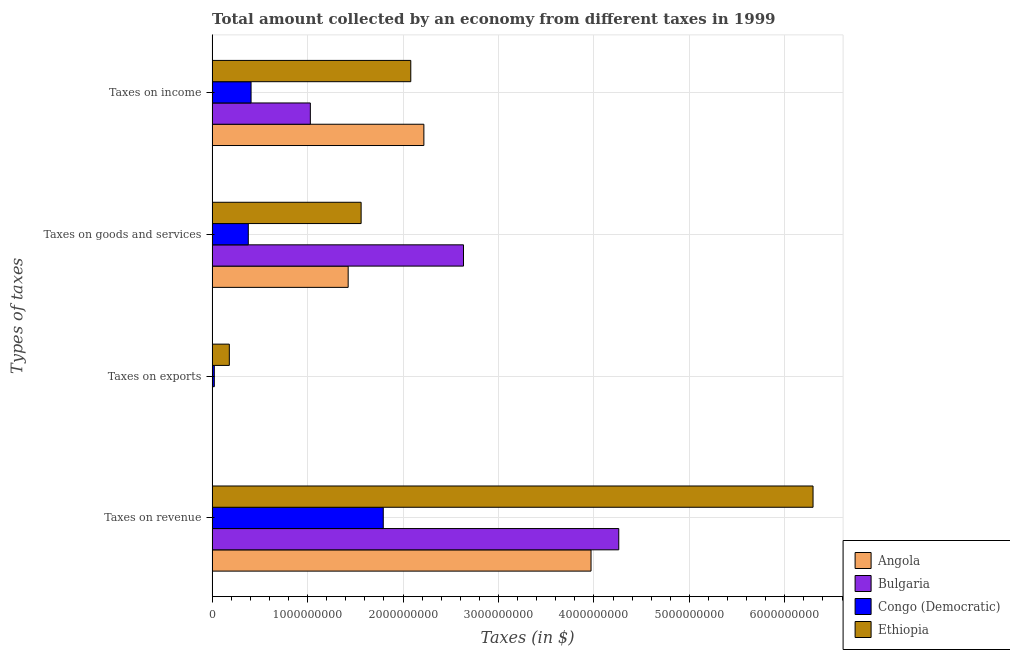How many different coloured bars are there?
Offer a very short reply. 4. Are the number of bars on each tick of the Y-axis equal?
Keep it short and to the point. Yes. How many bars are there on the 3rd tick from the bottom?
Make the answer very short. 4. What is the label of the 1st group of bars from the top?
Make the answer very short. Taxes on income. What is the amount collected as tax on goods in Congo (Democratic)?
Ensure brevity in your answer.  3.79e+08. Across all countries, what is the maximum amount collected as tax on income?
Offer a terse response. 2.22e+09. Across all countries, what is the minimum amount collected as tax on income?
Make the answer very short. 4.08e+08. In which country was the amount collected as tax on revenue maximum?
Provide a succinct answer. Ethiopia. In which country was the amount collected as tax on revenue minimum?
Offer a terse response. Congo (Democratic). What is the total amount collected as tax on goods in the graph?
Provide a short and direct response. 6.00e+09. What is the difference between the amount collected as tax on goods in Angola and that in Ethiopia?
Keep it short and to the point. -1.36e+08. What is the difference between the amount collected as tax on income in Ethiopia and the amount collected as tax on goods in Angola?
Offer a terse response. 6.56e+08. What is the average amount collected as tax on exports per country?
Provide a succinct answer. 5.16e+07. What is the difference between the amount collected as tax on revenue and amount collected as tax on income in Bulgaria?
Keep it short and to the point. 3.23e+09. What is the ratio of the amount collected as tax on goods in Congo (Democratic) to that in Ethiopia?
Your response must be concise. 0.24. Is the difference between the amount collected as tax on goods in Angola and Ethiopia greater than the difference between the amount collected as tax on revenue in Angola and Ethiopia?
Your answer should be very brief. Yes. What is the difference between the highest and the second highest amount collected as tax on revenue?
Make the answer very short. 2.04e+09. What is the difference between the highest and the lowest amount collected as tax on income?
Your answer should be very brief. 1.81e+09. What does the 3rd bar from the top in Taxes on exports represents?
Ensure brevity in your answer.  Bulgaria. What does the 4th bar from the bottom in Taxes on revenue represents?
Offer a very short reply. Ethiopia. Is it the case that in every country, the sum of the amount collected as tax on revenue and amount collected as tax on exports is greater than the amount collected as tax on goods?
Your answer should be very brief. Yes. Are all the bars in the graph horizontal?
Keep it short and to the point. Yes. How many countries are there in the graph?
Provide a short and direct response. 4. What is the difference between two consecutive major ticks on the X-axis?
Your response must be concise. 1.00e+09. Are the values on the major ticks of X-axis written in scientific E-notation?
Offer a very short reply. No. Does the graph contain grids?
Your answer should be compact. Yes. Where does the legend appear in the graph?
Offer a very short reply. Bottom right. How many legend labels are there?
Your answer should be very brief. 4. What is the title of the graph?
Provide a succinct answer. Total amount collected by an economy from different taxes in 1999. What is the label or title of the X-axis?
Your answer should be compact. Taxes (in $). What is the label or title of the Y-axis?
Keep it short and to the point. Types of taxes. What is the Taxes (in $) of Angola in Taxes on revenue?
Give a very brief answer. 3.97e+09. What is the Taxes (in $) in Bulgaria in Taxes on revenue?
Offer a terse response. 4.26e+09. What is the Taxes (in $) of Congo (Democratic) in Taxes on revenue?
Your response must be concise. 1.79e+09. What is the Taxes (in $) in Ethiopia in Taxes on revenue?
Your response must be concise. 6.30e+09. What is the Taxes (in $) in Angola in Taxes on exports?
Give a very brief answer. 3.22e+06. What is the Taxes (in $) in Bulgaria in Taxes on exports?
Your response must be concise. 6.80e+04. What is the Taxes (in $) of Congo (Democratic) in Taxes on exports?
Ensure brevity in your answer.  2.30e+07. What is the Taxes (in $) in Ethiopia in Taxes on exports?
Your answer should be very brief. 1.80e+08. What is the Taxes (in $) of Angola in Taxes on goods and services?
Provide a short and direct response. 1.43e+09. What is the Taxes (in $) of Bulgaria in Taxes on goods and services?
Provide a succinct answer. 2.63e+09. What is the Taxes (in $) of Congo (Democratic) in Taxes on goods and services?
Offer a very short reply. 3.79e+08. What is the Taxes (in $) of Ethiopia in Taxes on goods and services?
Make the answer very short. 1.56e+09. What is the Taxes (in $) of Angola in Taxes on income?
Provide a short and direct response. 2.22e+09. What is the Taxes (in $) in Bulgaria in Taxes on income?
Offer a very short reply. 1.03e+09. What is the Taxes (in $) in Congo (Democratic) in Taxes on income?
Keep it short and to the point. 4.08e+08. What is the Taxes (in $) in Ethiopia in Taxes on income?
Offer a very short reply. 2.08e+09. Across all Types of taxes, what is the maximum Taxes (in $) in Angola?
Make the answer very short. 3.97e+09. Across all Types of taxes, what is the maximum Taxes (in $) of Bulgaria?
Your answer should be very brief. 4.26e+09. Across all Types of taxes, what is the maximum Taxes (in $) in Congo (Democratic)?
Ensure brevity in your answer.  1.79e+09. Across all Types of taxes, what is the maximum Taxes (in $) of Ethiopia?
Your answer should be very brief. 6.30e+09. Across all Types of taxes, what is the minimum Taxes (in $) of Angola?
Provide a succinct answer. 3.22e+06. Across all Types of taxes, what is the minimum Taxes (in $) in Bulgaria?
Keep it short and to the point. 6.80e+04. Across all Types of taxes, what is the minimum Taxes (in $) in Congo (Democratic)?
Offer a terse response. 2.30e+07. Across all Types of taxes, what is the minimum Taxes (in $) in Ethiopia?
Provide a short and direct response. 1.80e+08. What is the total Taxes (in $) in Angola in the graph?
Keep it short and to the point. 7.62e+09. What is the total Taxes (in $) of Bulgaria in the graph?
Your response must be concise. 7.92e+09. What is the total Taxes (in $) in Congo (Democratic) in the graph?
Your answer should be very brief. 2.60e+09. What is the total Taxes (in $) in Ethiopia in the graph?
Provide a succinct answer. 1.01e+1. What is the difference between the Taxes (in $) in Angola in Taxes on revenue and that in Taxes on exports?
Make the answer very short. 3.97e+09. What is the difference between the Taxes (in $) of Bulgaria in Taxes on revenue and that in Taxes on exports?
Make the answer very short. 4.26e+09. What is the difference between the Taxes (in $) in Congo (Democratic) in Taxes on revenue and that in Taxes on exports?
Your answer should be very brief. 1.77e+09. What is the difference between the Taxes (in $) of Ethiopia in Taxes on revenue and that in Taxes on exports?
Provide a short and direct response. 6.12e+09. What is the difference between the Taxes (in $) in Angola in Taxes on revenue and that in Taxes on goods and services?
Make the answer very short. 2.54e+09. What is the difference between the Taxes (in $) of Bulgaria in Taxes on revenue and that in Taxes on goods and services?
Make the answer very short. 1.63e+09. What is the difference between the Taxes (in $) in Congo (Democratic) in Taxes on revenue and that in Taxes on goods and services?
Give a very brief answer. 1.41e+09. What is the difference between the Taxes (in $) of Ethiopia in Taxes on revenue and that in Taxes on goods and services?
Your response must be concise. 4.73e+09. What is the difference between the Taxes (in $) of Angola in Taxes on revenue and that in Taxes on income?
Your response must be concise. 1.75e+09. What is the difference between the Taxes (in $) of Bulgaria in Taxes on revenue and that in Taxes on income?
Provide a short and direct response. 3.23e+09. What is the difference between the Taxes (in $) in Congo (Democratic) in Taxes on revenue and that in Taxes on income?
Ensure brevity in your answer.  1.38e+09. What is the difference between the Taxes (in $) in Ethiopia in Taxes on revenue and that in Taxes on income?
Provide a short and direct response. 4.21e+09. What is the difference between the Taxes (in $) in Angola in Taxes on exports and that in Taxes on goods and services?
Your answer should be very brief. -1.42e+09. What is the difference between the Taxes (in $) in Bulgaria in Taxes on exports and that in Taxes on goods and services?
Provide a short and direct response. -2.63e+09. What is the difference between the Taxes (in $) of Congo (Democratic) in Taxes on exports and that in Taxes on goods and services?
Offer a very short reply. -3.56e+08. What is the difference between the Taxes (in $) in Ethiopia in Taxes on exports and that in Taxes on goods and services?
Keep it short and to the point. -1.38e+09. What is the difference between the Taxes (in $) in Angola in Taxes on exports and that in Taxes on income?
Your response must be concise. -2.22e+09. What is the difference between the Taxes (in $) of Bulgaria in Taxes on exports and that in Taxes on income?
Provide a short and direct response. -1.03e+09. What is the difference between the Taxes (in $) of Congo (Democratic) in Taxes on exports and that in Taxes on income?
Offer a terse response. -3.85e+08. What is the difference between the Taxes (in $) in Ethiopia in Taxes on exports and that in Taxes on income?
Ensure brevity in your answer.  -1.90e+09. What is the difference between the Taxes (in $) in Angola in Taxes on goods and services and that in Taxes on income?
Offer a terse response. -7.93e+08. What is the difference between the Taxes (in $) of Bulgaria in Taxes on goods and services and that in Taxes on income?
Keep it short and to the point. 1.60e+09. What is the difference between the Taxes (in $) in Congo (Democratic) in Taxes on goods and services and that in Taxes on income?
Make the answer very short. -2.90e+07. What is the difference between the Taxes (in $) in Ethiopia in Taxes on goods and services and that in Taxes on income?
Ensure brevity in your answer.  -5.20e+08. What is the difference between the Taxes (in $) of Angola in Taxes on revenue and the Taxes (in $) of Bulgaria in Taxes on exports?
Your answer should be very brief. 3.97e+09. What is the difference between the Taxes (in $) of Angola in Taxes on revenue and the Taxes (in $) of Congo (Democratic) in Taxes on exports?
Ensure brevity in your answer.  3.95e+09. What is the difference between the Taxes (in $) in Angola in Taxes on revenue and the Taxes (in $) in Ethiopia in Taxes on exports?
Offer a very short reply. 3.79e+09. What is the difference between the Taxes (in $) in Bulgaria in Taxes on revenue and the Taxes (in $) in Congo (Democratic) in Taxes on exports?
Ensure brevity in your answer.  4.24e+09. What is the difference between the Taxes (in $) of Bulgaria in Taxes on revenue and the Taxes (in $) of Ethiopia in Taxes on exports?
Give a very brief answer. 4.08e+09. What is the difference between the Taxes (in $) of Congo (Democratic) in Taxes on revenue and the Taxes (in $) of Ethiopia in Taxes on exports?
Your response must be concise. 1.61e+09. What is the difference between the Taxes (in $) of Angola in Taxes on revenue and the Taxes (in $) of Bulgaria in Taxes on goods and services?
Keep it short and to the point. 1.34e+09. What is the difference between the Taxes (in $) in Angola in Taxes on revenue and the Taxes (in $) in Congo (Democratic) in Taxes on goods and services?
Your response must be concise. 3.59e+09. What is the difference between the Taxes (in $) of Angola in Taxes on revenue and the Taxes (in $) of Ethiopia in Taxes on goods and services?
Your response must be concise. 2.41e+09. What is the difference between the Taxes (in $) in Bulgaria in Taxes on revenue and the Taxes (in $) in Congo (Democratic) in Taxes on goods and services?
Your answer should be compact. 3.88e+09. What is the difference between the Taxes (in $) in Bulgaria in Taxes on revenue and the Taxes (in $) in Ethiopia in Taxes on goods and services?
Keep it short and to the point. 2.70e+09. What is the difference between the Taxes (in $) in Congo (Democratic) in Taxes on revenue and the Taxes (in $) in Ethiopia in Taxes on goods and services?
Ensure brevity in your answer.  2.32e+08. What is the difference between the Taxes (in $) of Angola in Taxes on revenue and the Taxes (in $) of Bulgaria in Taxes on income?
Your response must be concise. 2.94e+09. What is the difference between the Taxes (in $) in Angola in Taxes on revenue and the Taxes (in $) in Congo (Democratic) in Taxes on income?
Provide a short and direct response. 3.56e+09. What is the difference between the Taxes (in $) in Angola in Taxes on revenue and the Taxes (in $) in Ethiopia in Taxes on income?
Offer a very short reply. 1.89e+09. What is the difference between the Taxes (in $) in Bulgaria in Taxes on revenue and the Taxes (in $) in Congo (Democratic) in Taxes on income?
Give a very brief answer. 3.85e+09. What is the difference between the Taxes (in $) in Bulgaria in Taxes on revenue and the Taxes (in $) in Ethiopia in Taxes on income?
Provide a succinct answer. 2.18e+09. What is the difference between the Taxes (in $) in Congo (Democratic) in Taxes on revenue and the Taxes (in $) in Ethiopia in Taxes on income?
Your answer should be very brief. -2.88e+08. What is the difference between the Taxes (in $) of Angola in Taxes on exports and the Taxes (in $) of Bulgaria in Taxes on goods and services?
Your response must be concise. -2.63e+09. What is the difference between the Taxes (in $) of Angola in Taxes on exports and the Taxes (in $) of Congo (Democratic) in Taxes on goods and services?
Your answer should be very brief. -3.76e+08. What is the difference between the Taxes (in $) in Angola in Taxes on exports and the Taxes (in $) in Ethiopia in Taxes on goods and services?
Ensure brevity in your answer.  -1.56e+09. What is the difference between the Taxes (in $) of Bulgaria in Taxes on exports and the Taxes (in $) of Congo (Democratic) in Taxes on goods and services?
Keep it short and to the point. -3.79e+08. What is the difference between the Taxes (in $) in Bulgaria in Taxes on exports and the Taxes (in $) in Ethiopia in Taxes on goods and services?
Provide a succinct answer. -1.56e+09. What is the difference between the Taxes (in $) of Congo (Democratic) in Taxes on exports and the Taxes (in $) of Ethiopia in Taxes on goods and services?
Ensure brevity in your answer.  -1.54e+09. What is the difference between the Taxes (in $) of Angola in Taxes on exports and the Taxes (in $) of Bulgaria in Taxes on income?
Give a very brief answer. -1.03e+09. What is the difference between the Taxes (in $) of Angola in Taxes on exports and the Taxes (in $) of Congo (Democratic) in Taxes on income?
Offer a very short reply. -4.05e+08. What is the difference between the Taxes (in $) in Angola in Taxes on exports and the Taxes (in $) in Ethiopia in Taxes on income?
Provide a short and direct response. -2.08e+09. What is the difference between the Taxes (in $) in Bulgaria in Taxes on exports and the Taxes (in $) in Congo (Democratic) in Taxes on income?
Provide a succinct answer. -4.08e+08. What is the difference between the Taxes (in $) in Bulgaria in Taxes on exports and the Taxes (in $) in Ethiopia in Taxes on income?
Keep it short and to the point. -2.08e+09. What is the difference between the Taxes (in $) of Congo (Democratic) in Taxes on exports and the Taxes (in $) of Ethiopia in Taxes on income?
Offer a very short reply. -2.06e+09. What is the difference between the Taxes (in $) in Angola in Taxes on goods and services and the Taxes (in $) in Bulgaria in Taxes on income?
Give a very brief answer. 3.96e+08. What is the difference between the Taxes (in $) of Angola in Taxes on goods and services and the Taxes (in $) of Congo (Democratic) in Taxes on income?
Ensure brevity in your answer.  1.02e+09. What is the difference between the Taxes (in $) in Angola in Taxes on goods and services and the Taxes (in $) in Ethiopia in Taxes on income?
Offer a very short reply. -6.56e+08. What is the difference between the Taxes (in $) of Bulgaria in Taxes on goods and services and the Taxes (in $) of Congo (Democratic) in Taxes on income?
Your answer should be very brief. 2.23e+09. What is the difference between the Taxes (in $) of Bulgaria in Taxes on goods and services and the Taxes (in $) of Ethiopia in Taxes on income?
Make the answer very short. 5.52e+08. What is the difference between the Taxes (in $) in Congo (Democratic) in Taxes on goods and services and the Taxes (in $) in Ethiopia in Taxes on income?
Your answer should be compact. -1.70e+09. What is the average Taxes (in $) in Angola per Types of taxes?
Provide a succinct answer. 1.90e+09. What is the average Taxes (in $) in Bulgaria per Types of taxes?
Offer a very short reply. 1.98e+09. What is the average Taxes (in $) in Congo (Democratic) per Types of taxes?
Make the answer very short. 6.51e+08. What is the average Taxes (in $) of Ethiopia per Types of taxes?
Your answer should be compact. 2.53e+09. What is the difference between the Taxes (in $) in Angola and Taxes (in $) in Bulgaria in Taxes on revenue?
Your answer should be compact. -2.91e+08. What is the difference between the Taxes (in $) of Angola and Taxes (in $) of Congo (Democratic) in Taxes on revenue?
Make the answer very short. 2.18e+09. What is the difference between the Taxes (in $) in Angola and Taxes (in $) in Ethiopia in Taxes on revenue?
Offer a terse response. -2.33e+09. What is the difference between the Taxes (in $) of Bulgaria and Taxes (in $) of Congo (Democratic) in Taxes on revenue?
Offer a terse response. 2.47e+09. What is the difference between the Taxes (in $) of Bulgaria and Taxes (in $) of Ethiopia in Taxes on revenue?
Give a very brief answer. -2.04e+09. What is the difference between the Taxes (in $) in Congo (Democratic) and Taxes (in $) in Ethiopia in Taxes on revenue?
Make the answer very short. -4.50e+09. What is the difference between the Taxes (in $) of Angola and Taxes (in $) of Bulgaria in Taxes on exports?
Provide a short and direct response. 3.15e+06. What is the difference between the Taxes (in $) of Angola and Taxes (in $) of Congo (Democratic) in Taxes on exports?
Offer a terse response. -1.98e+07. What is the difference between the Taxes (in $) in Angola and Taxes (in $) in Ethiopia in Taxes on exports?
Ensure brevity in your answer.  -1.77e+08. What is the difference between the Taxes (in $) in Bulgaria and Taxes (in $) in Congo (Democratic) in Taxes on exports?
Give a very brief answer. -2.29e+07. What is the difference between the Taxes (in $) in Bulgaria and Taxes (in $) in Ethiopia in Taxes on exports?
Keep it short and to the point. -1.80e+08. What is the difference between the Taxes (in $) in Congo (Democratic) and Taxes (in $) in Ethiopia in Taxes on exports?
Provide a short and direct response. -1.57e+08. What is the difference between the Taxes (in $) of Angola and Taxes (in $) of Bulgaria in Taxes on goods and services?
Ensure brevity in your answer.  -1.21e+09. What is the difference between the Taxes (in $) in Angola and Taxes (in $) in Congo (Democratic) in Taxes on goods and services?
Give a very brief answer. 1.05e+09. What is the difference between the Taxes (in $) of Angola and Taxes (in $) of Ethiopia in Taxes on goods and services?
Make the answer very short. -1.36e+08. What is the difference between the Taxes (in $) in Bulgaria and Taxes (in $) in Congo (Democratic) in Taxes on goods and services?
Offer a terse response. 2.25e+09. What is the difference between the Taxes (in $) of Bulgaria and Taxes (in $) of Ethiopia in Taxes on goods and services?
Provide a short and direct response. 1.07e+09. What is the difference between the Taxes (in $) in Congo (Democratic) and Taxes (in $) in Ethiopia in Taxes on goods and services?
Your answer should be very brief. -1.18e+09. What is the difference between the Taxes (in $) of Angola and Taxes (in $) of Bulgaria in Taxes on income?
Provide a succinct answer. 1.19e+09. What is the difference between the Taxes (in $) in Angola and Taxes (in $) in Congo (Democratic) in Taxes on income?
Your answer should be very brief. 1.81e+09. What is the difference between the Taxes (in $) in Angola and Taxes (in $) in Ethiopia in Taxes on income?
Provide a short and direct response. 1.37e+08. What is the difference between the Taxes (in $) in Bulgaria and Taxes (in $) in Congo (Democratic) in Taxes on income?
Provide a short and direct response. 6.21e+08. What is the difference between the Taxes (in $) in Bulgaria and Taxes (in $) in Ethiopia in Taxes on income?
Your response must be concise. -1.05e+09. What is the difference between the Taxes (in $) in Congo (Democratic) and Taxes (in $) in Ethiopia in Taxes on income?
Provide a succinct answer. -1.67e+09. What is the ratio of the Taxes (in $) in Angola in Taxes on revenue to that in Taxes on exports?
Your answer should be very brief. 1233.37. What is the ratio of the Taxes (in $) of Bulgaria in Taxes on revenue to that in Taxes on exports?
Make the answer very short. 6.27e+04. What is the ratio of the Taxes (in $) in Congo (Democratic) in Taxes on revenue to that in Taxes on exports?
Your response must be concise. 77.96. What is the ratio of the Taxes (in $) of Ethiopia in Taxes on revenue to that in Taxes on exports?
Make the answer very short. 34.92. What is the ratio of the Taxes (in $) of Angola in Taxes on revenue to that in Taxes on goods and services?
Keep it short and to the point. 2.79. What is the ratio of the Taxes (in $) in Bulgaria in Taxes on revenue to that in Taxes on goods and services?
Keep it short and to the point. 1.62. What is the ratio of the Taxes (in $) in Congo (Democratic) in Taxes on revenue to that in Taxes on goods and services?
Your response must be concise. 4.73. What is the ratio of the Taxes (in $) in Ethiopia in Taxes on revenue to that in Taxes on goods and services?
Your answer should be compact. 4.03. What is the ratio of the Taxes (in $) of Angola in Taxes on revenue to that in Taxes on income?
Provide a short and direct response. 1.79. What is the ratio of the Taxes (in $) of Bulgaria in Taxes on revenue to that in Taxes on income?
Keep it short and to the point. 4.14. What is the ratio of the Taxes (in $) of Congo (Democratic) in Taxes on revenue to that in Taxes on income?
Provide a succinct answer. 4.39. What is the ratio of the Taxes (in $) of Ethiopia in Taxes on revenue to that in Taxes on income?
Ensure brevity in your answer.  3.02. What is the ratio of the Taxes (in $) in Angola in Taxes on exports to that in Taxes on goods and services?
Offer a terse response. 0. What is the ratio of the Taxes (in $) of Bulgaria in Taxes on exports to that in Taxes on goods and services?
Ensure brevity in your answer.  0. What is the ratio of the Taxes (in $) of Congo (Democratic) in Taxes on exports to that in Taxes on goods and services?
Give a very brief answer. 0.06. What is the ratio of the Taxes (in $) in Ethiopia in Taxes on exports to that in Taxes on goods and services?
Give a very brief answer. 0.12. What is the ratio of the Taxes (in $) in Angola in Taxes on exports to that in Taxes on income?
Offer a terse response. 0. What is the ratio of the Taxes (in $) of Congo (Democratic) in Taxes on exports to that in Taxes on income?
Your response must be concise. 0.06. What is the ratio of the Taxes (in $) in Ethiopia in Taxes on exports to that in Taxes on income?
Offer a very short reply. 0.09. What is the ratio of the Taxes (in $) of Angola in Taxes on goods and services to that in Taxes on income?
Keep it short and to the point. 0.64. What is the ratio of the Taxes (in $) of Bulgaria in Taxes on goods and services to that in Taxes on income?
Provide a succinct answer. 2.56. What is the ratio of the Taxes (in $) in Congo (Democratic) in Taxes on goods and services to that in Taxes on income?
Ensure brevity in your answer.  0.93. What is the difference between the highest and the second highest Taxes (in $) in Angola?
Provide a succinct answer. 1.75e+09. What is the difference between the highest and the second highest Taxes (in $) in Bulgaria?
Give a very brief answer. 1.63e+09. What is the difference between the highest and the second highest Taxes (in $) of Congo (Democratic)?
Offer a terse response. 1.38e+09. What is the difference between the highest and the second highest Taxes (in $) in Ethiopia?
Your response must be concise. 4.21e+09. What is the difference between the highest and the lowest Taxes (in $) in Angola?
Provide a short and direct response. 3.97e+09. What is the difference between the highest and the lowest Taxes (in $) of Bulgaria?
Offer a very short reply. 4.26e+09. What is the difference between the highest and the lowest Taxes (in $) of Congo (Democratic)?
Make the answer very short. 1.77e+09. What is the difference between the highest and the lowest Taxes (in $) in Ethiopia?
Provide a short and direct response. 6.12e+09. 